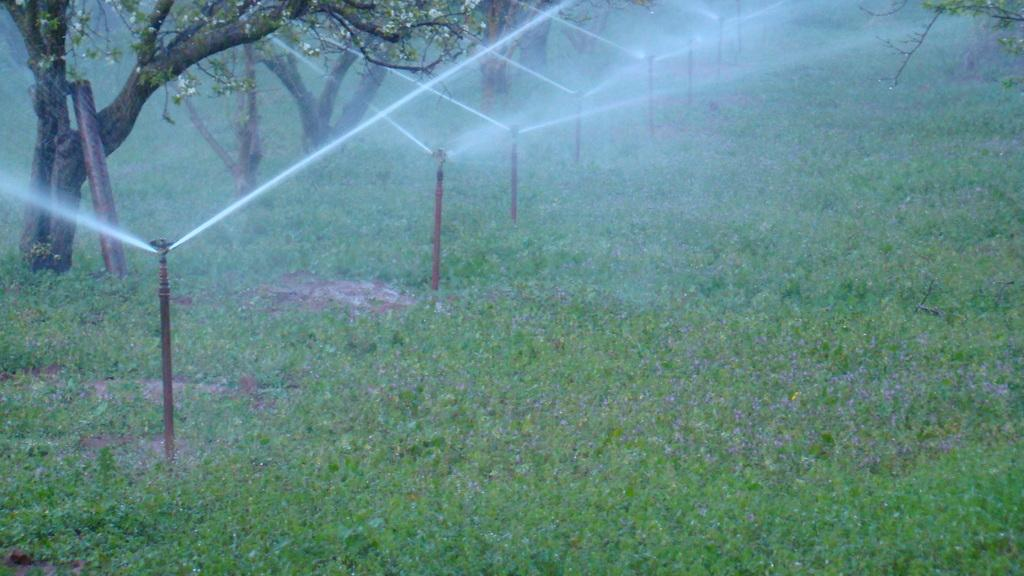What is the main subject of the image? The main subject of the image is water sprinkler pipes. What are the water sprinkler pipes doing? The water sprinkler pipes are sprinkling water. Where is the water being sprinkled? The water is sprinkling on the grass. What else can be seen in the image besides the water sprinkler pipes? There are trees in the image, and one pipe is near a tree. How many drinks can be seen in the image? There are no drinks visible in the image; it features water sprinkler pipes and grass. Can you tell me how many times the trees need to be folded in the image? Trees cannot be folded, so this question is not applicable to the image. 